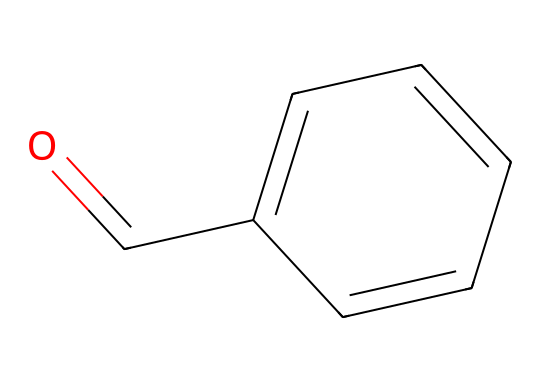What is the molecular formula of benzaldehyde? To determine the molecular formula, we identify each type of atom in the structure. The structure shows 7 carbon (C) atoms, 6 hydrogen (H) atoms, and 1 oxygen (O) atom. Therefore, the molecular formula is C7H6O.
Answer: C7H6O How many aromatic rings are present in benzaldehyde? The structure includes a six-membered carbon ring with alternating double bonds, which indicates it is an aromatic ring. There is only one such ring in benzaldehyde.
Answer: 1 What functional group is present in benzaldehyde? The structure has a carbonyl group (C=O) attached to a carbon atom of an aromatic ring, which defines the aldehyde functional group. Thus, benzaldehyde contains the aldehyde functional group.
Answer: aldehyde How many total double bonds are in the benzaldehyde structure? In the structure, there is one carbonyl double bond (C=O) and three double bonds in the aromatic ring structure (contributing to the ring's stability). Adding them, there are four double bonds total.
Answer: 4 What is the main scent associated with benzaldehyde? Benzaldehyde is known for its characteristic almond scent, which is also commonly used in air fresheners. Thus, the scent associated with benzaldehyde is almond.
Answer: almond What type of reaction is typically used to synthesize benzaldehyde? Benzaldehyde can be synthesized via the oxidation of benzyl alcohol, which is a common method in organic chemistry for aldehydes. Thus, the type of reaction is oxidation.
Answer: oxidation 